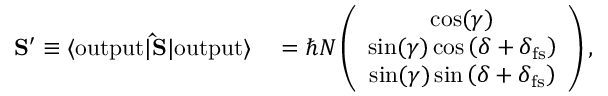<formula> <loc_0><loc_0><loc_500><loc_500>\begin{array} { r l } { { S } ^ { \prime } \equiv \langle o u t p u t | { \hat { S } } | o u t p u t \rangle } & = \hbar { N } \left ( \begin{array} { c } { \cos ( \gamma ) } \\ { \sin ( \gamma ) \cos \left ( \delta + \delta _ { f s } \right ) } \\ { \sin ( \gamma ) \sin \left ( \delta + \delta _ { f s } \right ) } \end{array} \right ) , } \end{array}</formula> 